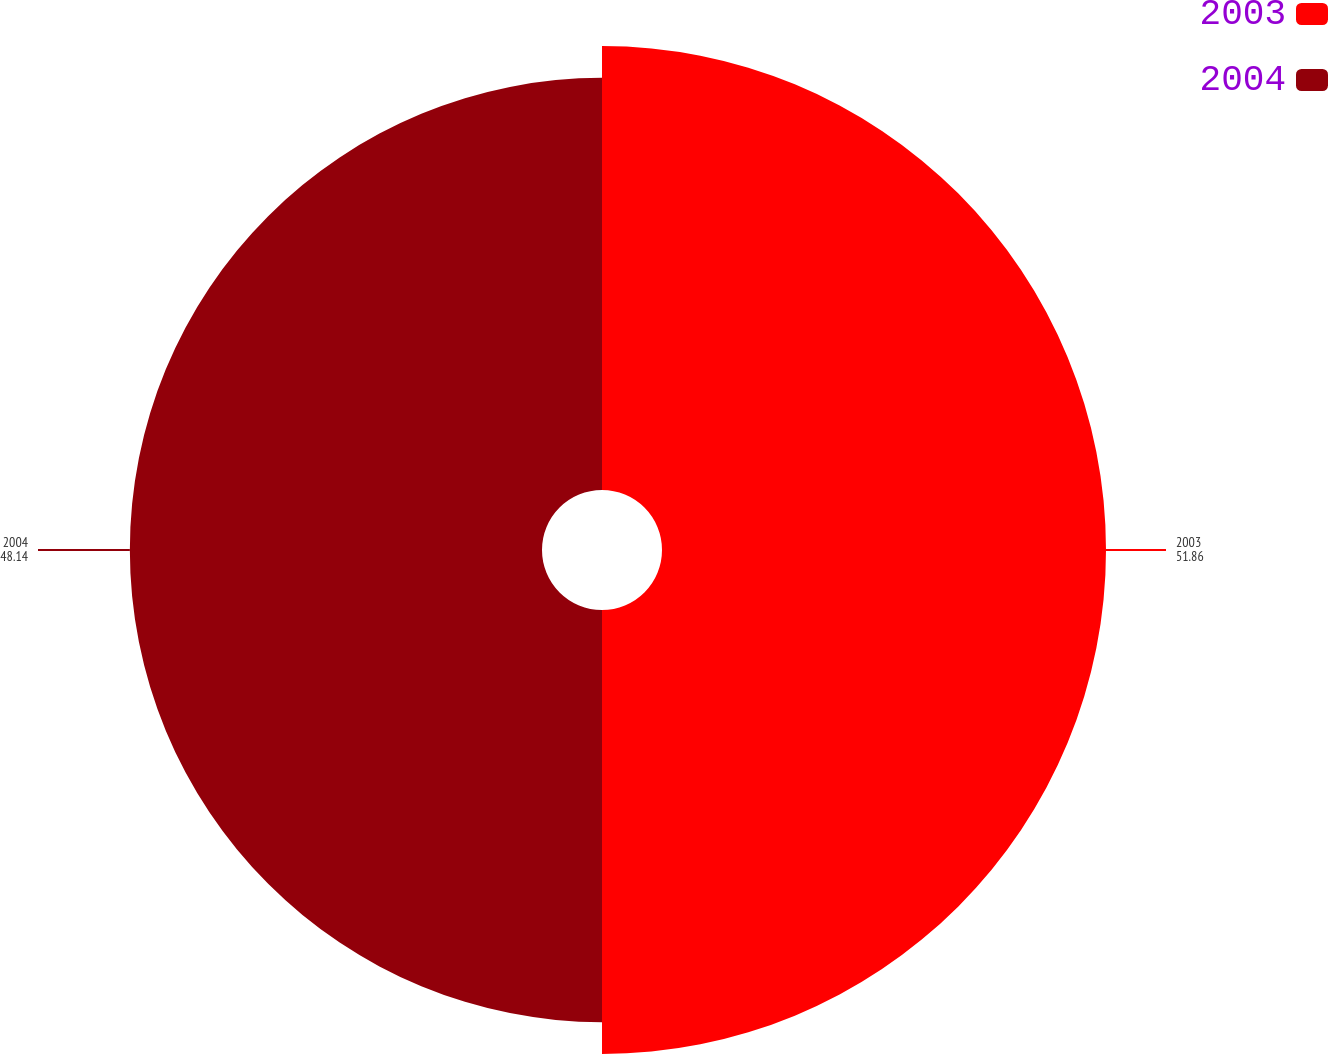<chart> <loc_0><loc_0><loc_500><loc_500><pie_chart><fcel>2003<fcel>2004<nl><fcel>51.86%<fcel>48.14%<nl></chart> 